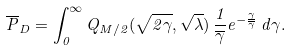Convert formula to latex. <formula><loc_0><loc_0><loc_500><loc_500>\overline { P } _ { D } = \int _ { 0 } ^ { \infty } Q _ { M / 2 } ( \sqrt { 2 \gamma } , \sqrt { \lambda } ) \, \frac { 1 } { \overline { \gamma } } e ^ { - \frac { \gamma } { \overline { \gamma } } } \, d \gamma .</formula> 